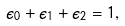<formula> <loc_0><loc_0><loc_500><loc_500>\epsilon _ { 0 } + \epsilon _ { 1 } + \epsilon _ { 2 } = 1 ,</formula> 